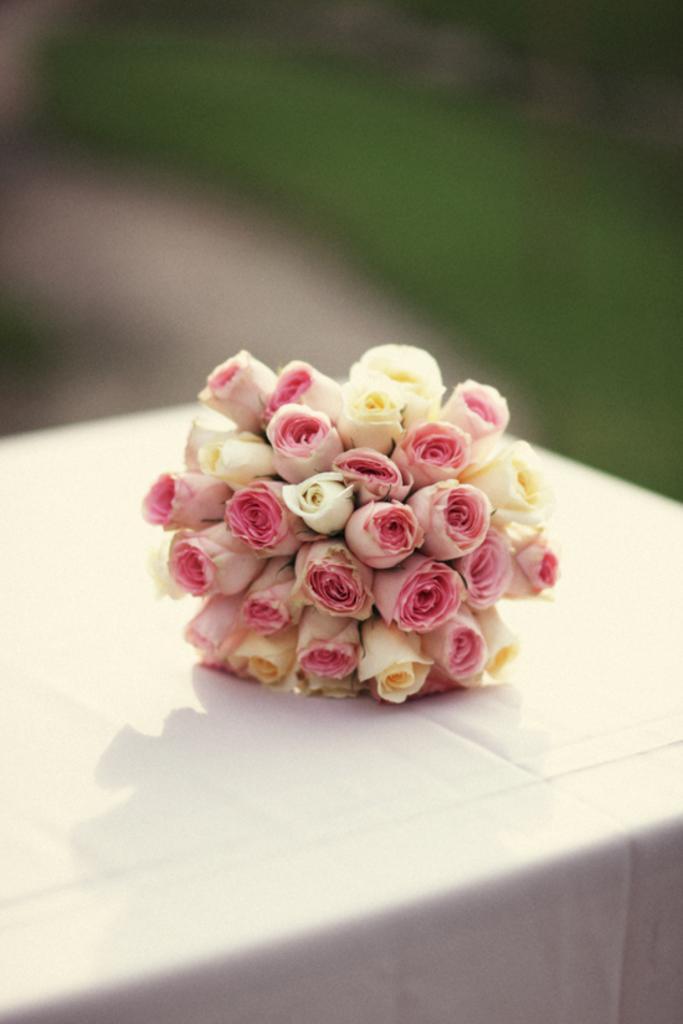Please provide a concise description of this image. In this picture there are pink and yellow color roses on the table and the table is covered with white color cloth. At the back the picture is blurry. 